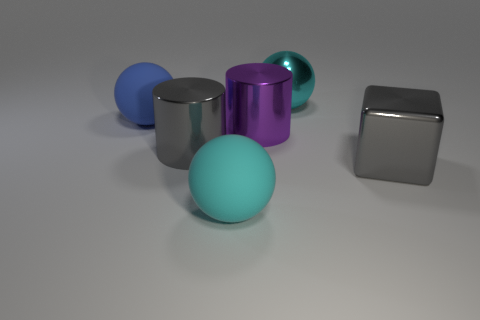How many other things are there of the same color as the big block?
Offer a very short reply. 1. What size is the purple thing?
Provide a short and direct response. Large. Is there a small gray matte cylinder?
Your answer should be compact. No. Are there more cyan spheres that are in front of the cyan metallic thing than purple objects behind the blue thing?
Offer a very short reply. Yes. There is a big ball that is both behind the gray block and right of the blue matte thing; what material is it made of?
Your response must be concise. Metal. Is the large cyan matte object the same shape as the blue rubber object?
Your response must be concise. Yes. How many blue objects are behind the big gray shiny block?
Ensure brevity in your answer.  1. There is a metallic cylinder on the right side of the cyan matte thing; is its size the same as the large blue ball?
Ensure brevity in your answer.  Yes. What color is the other large shiny object that is the same shape as the big purple thing?
Your answer should be very brief. Gray. The matte object right of the big blue rubber thing has what shape?
Keep it short and to the point. Sphere. 